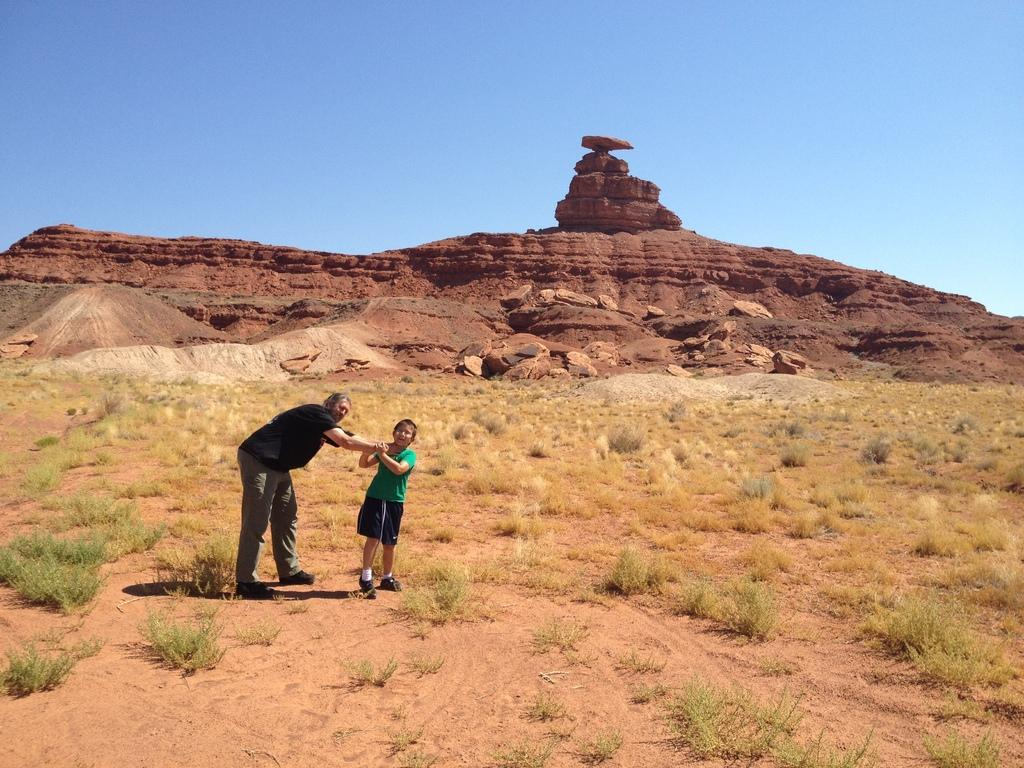What is the main subject of the image? There is a man in the image. What is the man doing in the image? The man is holding the neck of a child. What type of terrain is visible in the image? There is grass visible in the image. What can be seen in the distance in the image? There are hills in the background of the image. What is the condition of the sky in the image? The sky appears cloudy in the image. What type of meat is the man grilling in the image? There is no meat or grill present in the image. What drink is the child holding in the image? There is no drink visible in the image. 